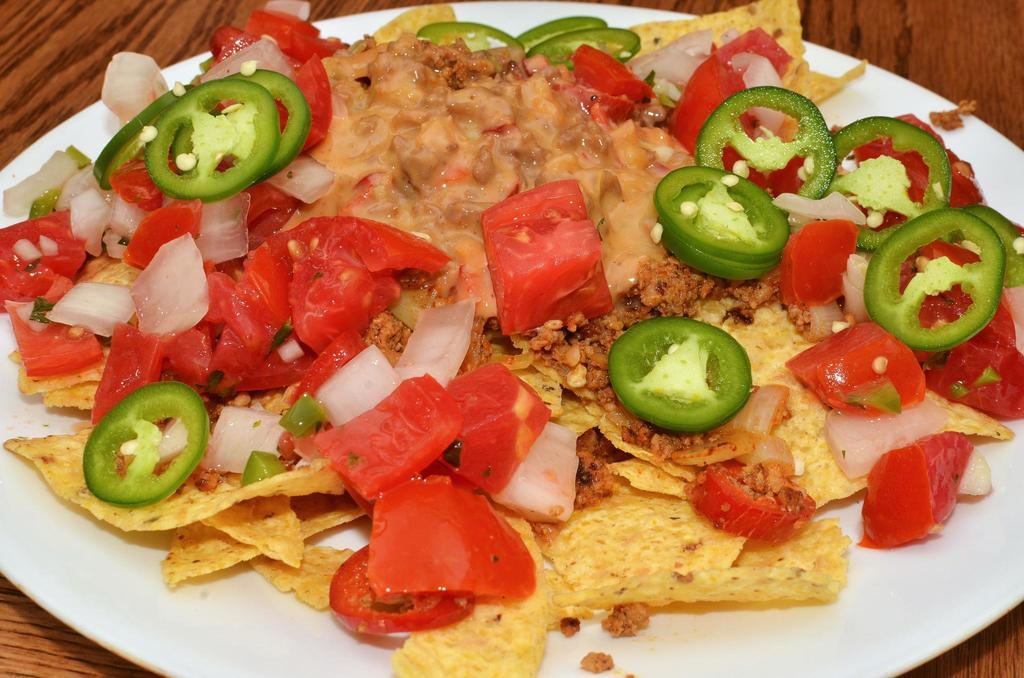What type of furniture is present in the image? There is a table in the image. What is placed on the table? There is a white color plate on the table. What is inside the plate? There is a dish in the plate. How does the dish learn to cry in the image? There is no indication in the image that the dish is capable of learning or crying, as it is an inanimate object. 